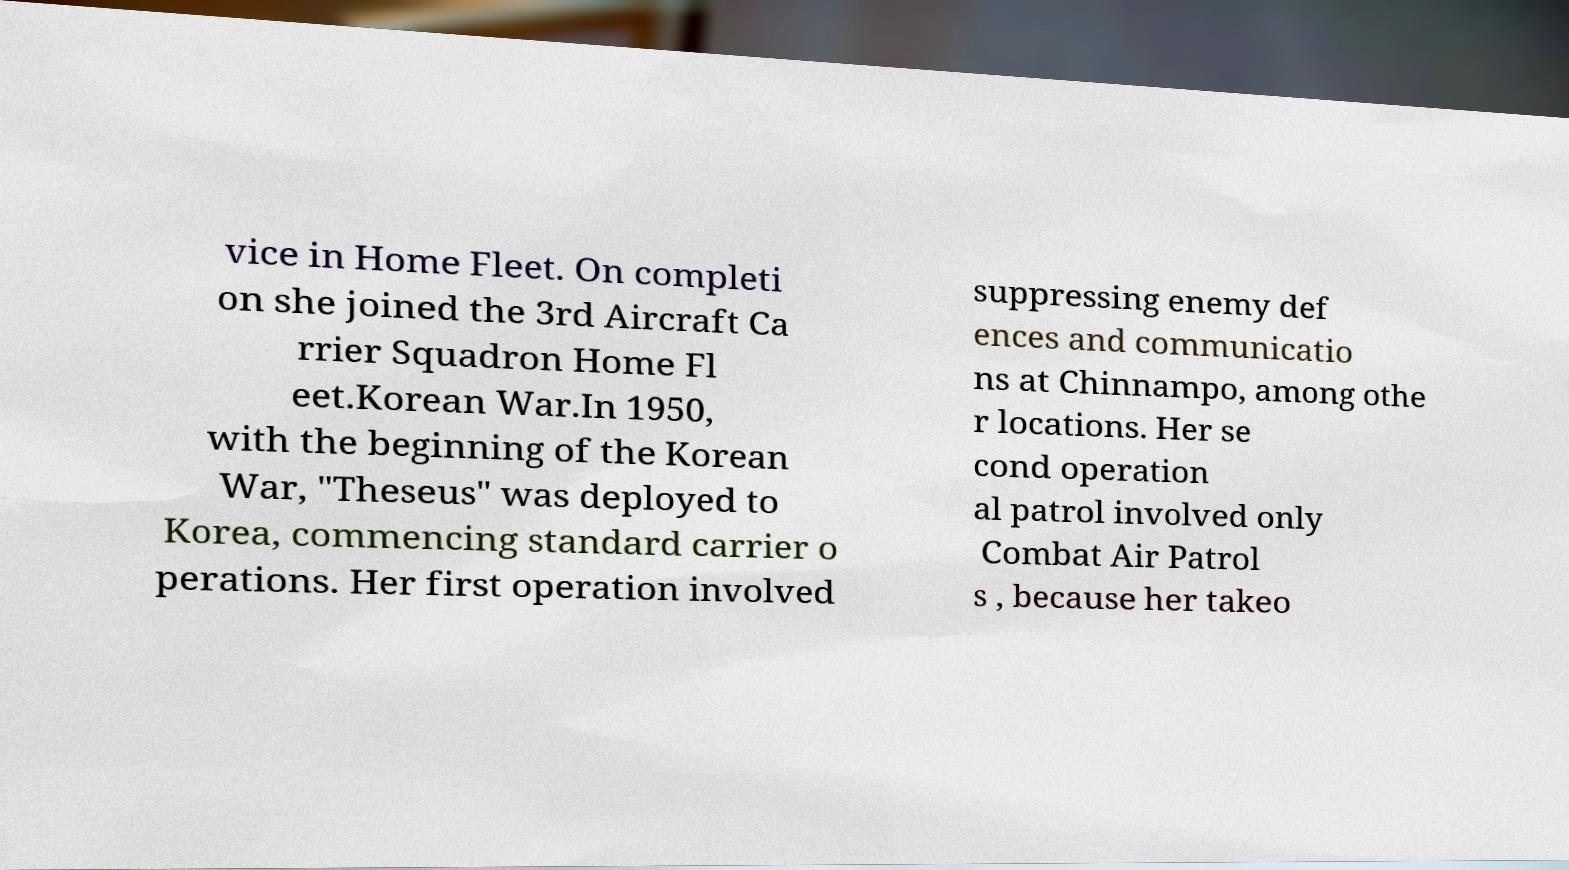Could you assist in decoding the text presented in this image and type it out clearly? vice in Home Fleet. On completi on she joined the 3rd Aircraft Ca rrier Squadron Home Fl eet.Korean War.In 1950, with the beginning of the Korean War, "Theseus" was deployed to Korea, commencing standard carrier o perations. Her first operation involved suppressing enemy def ences and communicatio ns at Chinnampo, among othe r locations. Her se cond operation al patrol involved only Combat Air Patrol s , because her takeo 